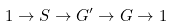Convert formula to latex. <formula><loc_0><loc_0><loc_500><loc_500>1 \to S \to G ^ { \prime } \to G \to 1</formula> 